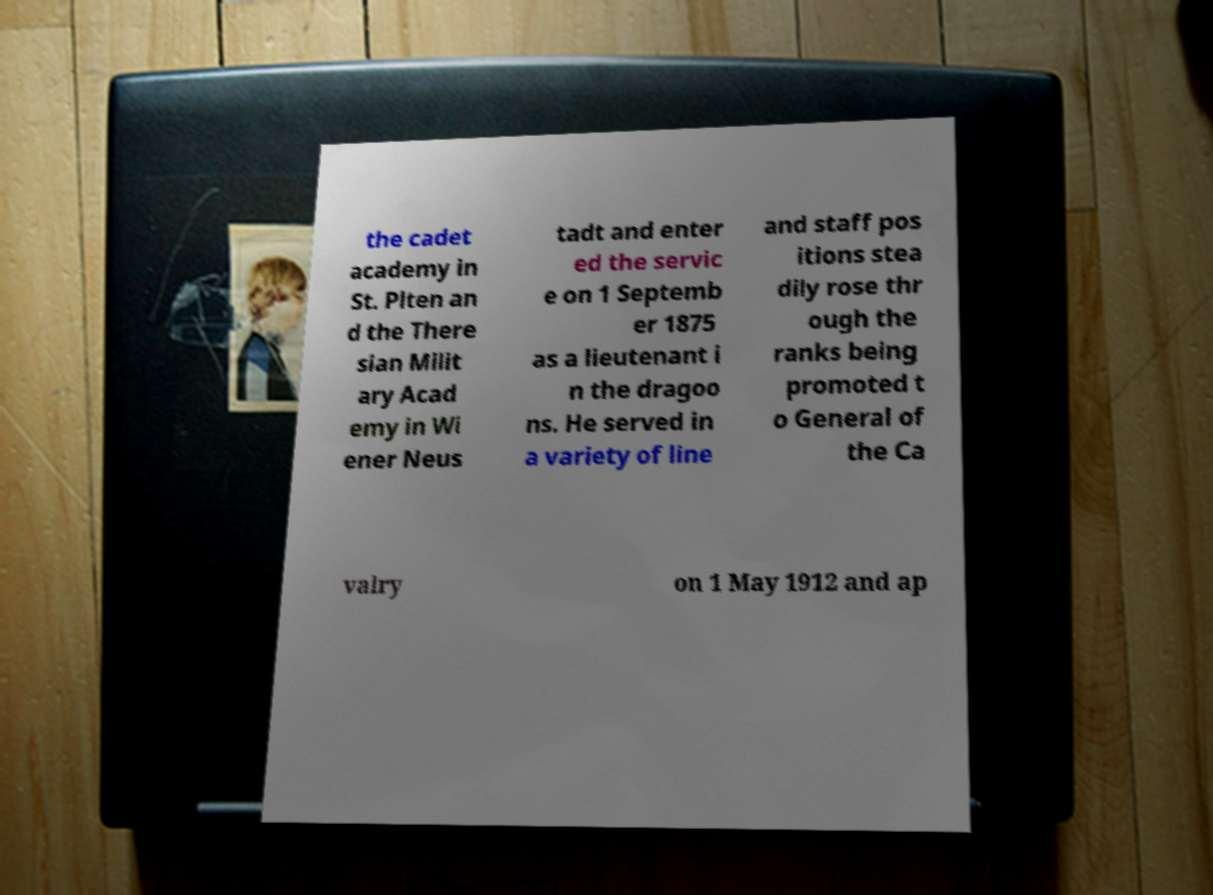What messages or text are displayed in this image? I need them in a readable, typed format. the cadet academy in St. Plten an d the There sian Milit ary Acad emy in Wi ener Neus tadt and enter ed the servic e on 1 Septemb er 1875 as a lieutenant i n the dragoo ns. He served in a variety of line and staff pos itions stea dily rose thr ough the ranks being promoted t o General of the Ca valry on 1 May 1912 and ap 